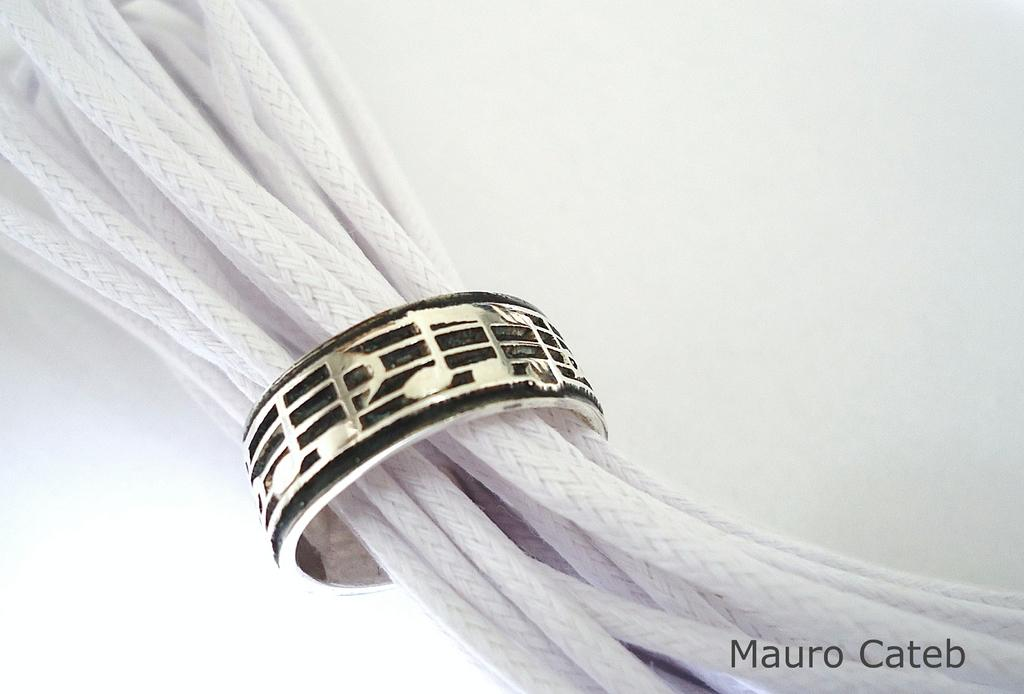What objects can be seen in the image? There are ropes and a ring in the image. Can you describe the ring in the image? The ring is in the middle of the image. Can you hear the planes flying in the image? There are no planes or sounds present in the image, as it only features ropes and a ring. 